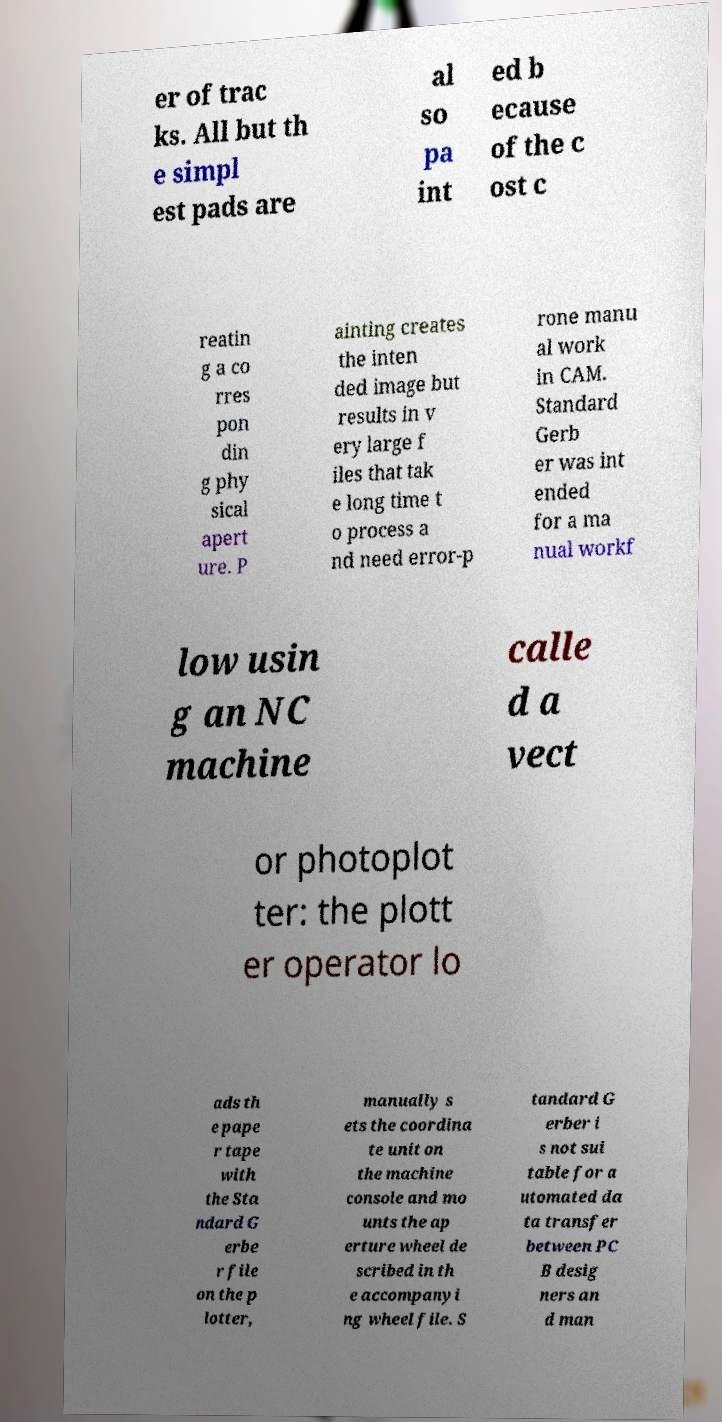Please identify and transcribe the text found in this image. er of trac ks. All but th e simpl est pads are al so pa int ed b ecause of the c ost c reatin g a co rres pon din g phy sical apert ure. P ainting creates the inten ded image but results in v ery large f iles that tak e long time t o process a nd need error-p rone manu al work in CAM. Standard Gerb er was int ended for a ma nual workf low usin g an NC machine calle d a vect or photoplot ter: the plott er operator lo ads th e pape r tape with the Sta ndard G erbe r file on the p lotter, manually s ets the coordina te unit on the machine console and mo unts the ap erture wheel de scribed in th e accompanyi ng wheel file. S tandard G erber i s not sui table for a utomated da ta transfer between PC B desig ners an d man 